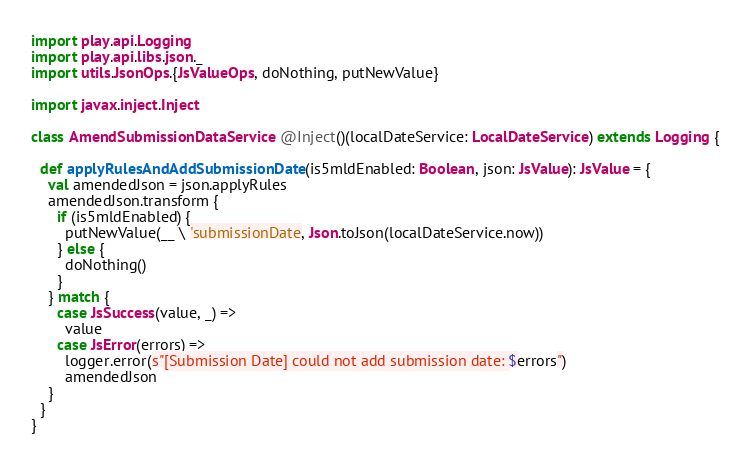<code> <loc_0><loc_0><loc_500><loc_500><_Scala_>
import play.api.Logging
import play.api.libs.json._
import utils.JsonOps.{JsValueOps, doNothing, putNewValue}

import javax.inject.Inject

class AmendSubmissionDataService @Inject()(localDateService: LocalDateService) extends Logging {

  def applyRulesAndAddSubmissionDate(is5mldEnabled: Boolean, json: JsValue): JsValue = {
    val amendedJson = json.applyRules
    amendedJson.transform {
      if (is5mldEnabled) {
        putNewValue(__ \ 'submissionDate, Json.toJson(localDateService.now))
      } else {
        doNothing()
      }
    } match {
      case JsSuccess(value, _) =>
        value
      case JsError(errors) =>
        logger.error(s"[Submission Date] could not add submission date: $errors")
        amendedJson
    }
  }
}
</code> 